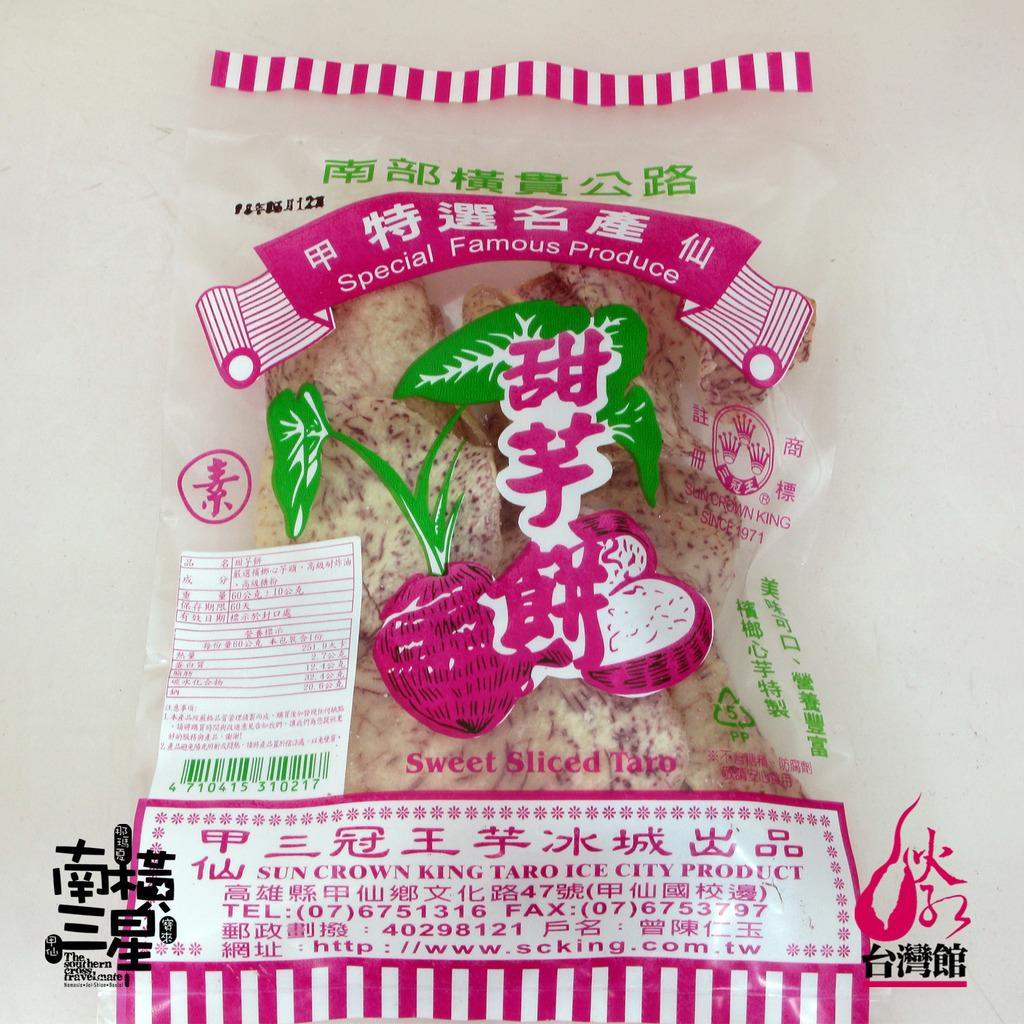Provide a one-sentence caption for the provided image. A pink and white package of food from Sun Crown King. 